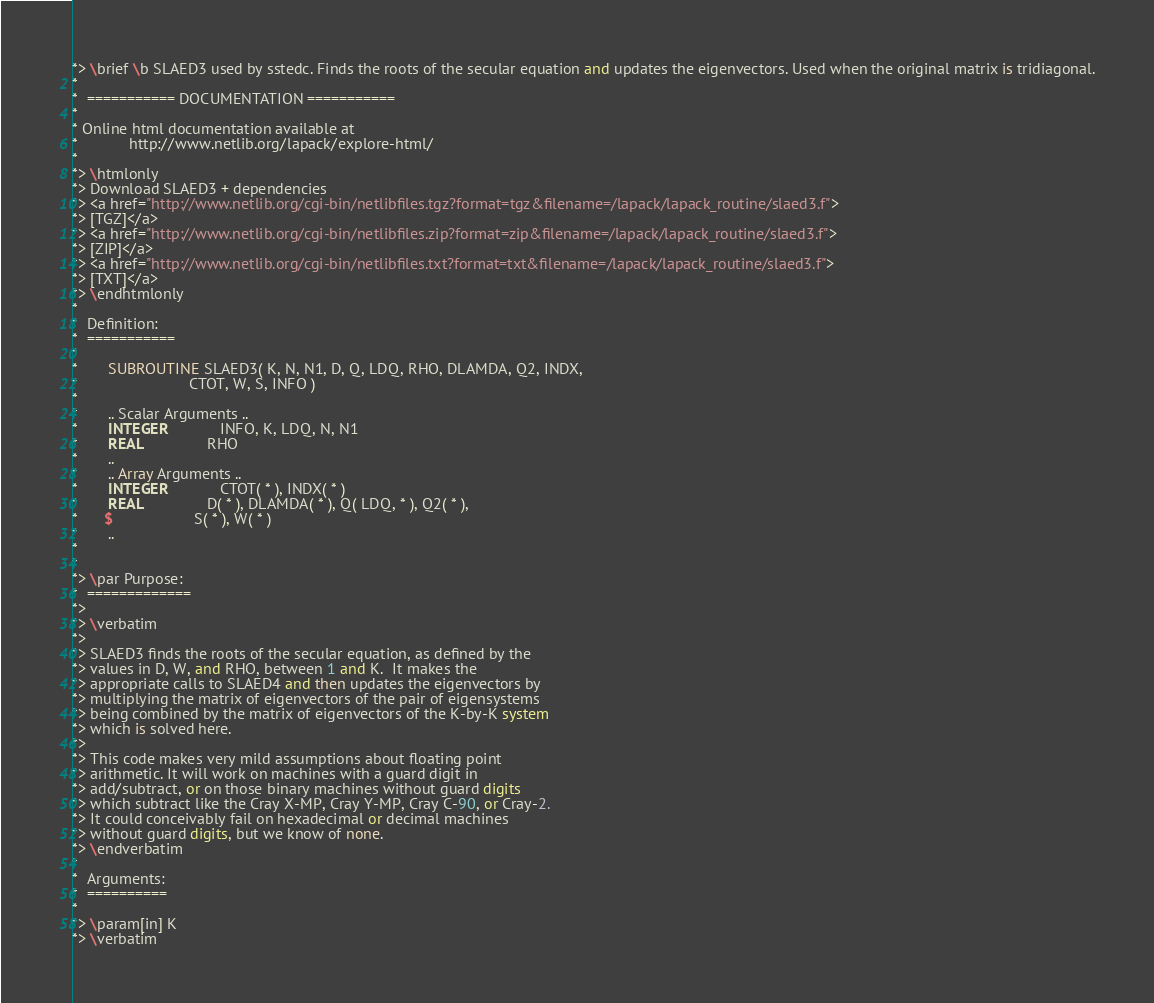Convert code to text. <code><loc_0><loc_0><loc_500><loc_500><_FORTRAN_>*> \brief \b SLAED3 used by sstedc. Finds the roots of the secular equation and updates the eigenvectors. Used when the original matrix is tridiagonal.
*
*  =========== DOCUMENTATION ===========
*
* Online html documentation available at
*            http://www.netlib.org/lapack/explore-html/
*
*> \htmlonly
*> Download SLAED3 + dependencies
*> <a href="http://www.netlib.org/cgi-bin/netlibfiles.tgz?format=tgz&filename=/lapack/lapack_routine/slaed3.f">
*> [TGZ]</a>
*> <a href="http://www.netlib.org/cgi-bin/netlibfiles.zip?format=zip&filename=/lapack/lapack_routine/slaed3.f">
*> [ZIP]</a>
*> <a href="http://www.netlib.org/cgi-bin/netlibfiles.txt?format=txt&filename=/lapack/lapack_routine/slaed3.f">
*> [TXT]</a>
*> \endhtmlonly
*
*  Definition:
*  ===========
*
*       SUBROUTINE SLAED3( K, N, N1, D, Q, LDQ, RHO, DLAMDA, Q2, INDX,
*                          CTOT, W, S, INFO )
*
*       .. Scalar Arguments ..
*       INTEGER            INFO, K, LDQ, N, N1
*       REAL               RHO
*       ..
*       .. Array Arguments ..
*       INTEGER            CTOT( * ), INDX( * )
*       REAL               D( * ), DLAMDA( * ), Q( LDQ, * ), Q2( * ),
*      $                   S( * ), W( * )
*       ..
*
*
*> \par Purpose:
*  =============
*>
*> \verbatim
*>
*> SLAED3 finds the roots of the secular equation, as defined by the
*> values in D, W, and RHO, between 1 and K.  It makes the
*> appropriate calls to SLAED4 and then updates the eigenvectors by
*> multiplying the matrix of eigenvectors of the pair of eigensystems
*> being combined by the matrix of eigenvectors of the K-by-K system
*> which is solved here.
*>
*> This code makes very mild assumptions about floating point
*> arithmetic. It will work on machines with a guard digit in
*> add/subtract, or on those binary machines without guard digits
*> which subtract like the Cray X-MP, Cray Y-MP, Cray C-90, or Cray-2.
*> It could conceivably fail on hexadecimal or decimal machines
*> without guard digits, but we know of none.
*> \endverbatim
*
*  Arguments:
*  ==========
*
*> \param[in] K
*> \verbatim</code> 